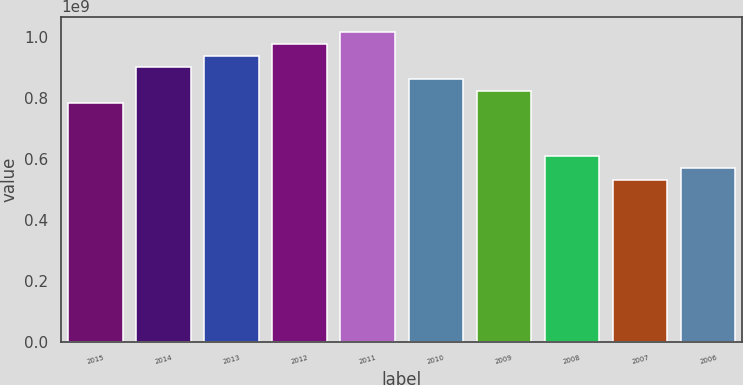Convert chart. <chart><loc_0><loc_0><loc_500><loc_500><bar_chart><fcel>2015<fcel>2014<fcel>2013<fcel>2012<fcel>2011<fcel>2010<fcel>2009<fcel>2008<fcel>2007<fcel>2006<nl><fcel>7.8508e+08<fcel>9.0122e+08<fcel>9.39933e+08<fcel>9.78647e+08<fcel>1.01736e+09<fcel>8.62507e+08<fcel>8.23794e+08<fcel>6.10098e+08<fcel>5.32672e+08<fcel>5.71385e+08<nl></chart> 